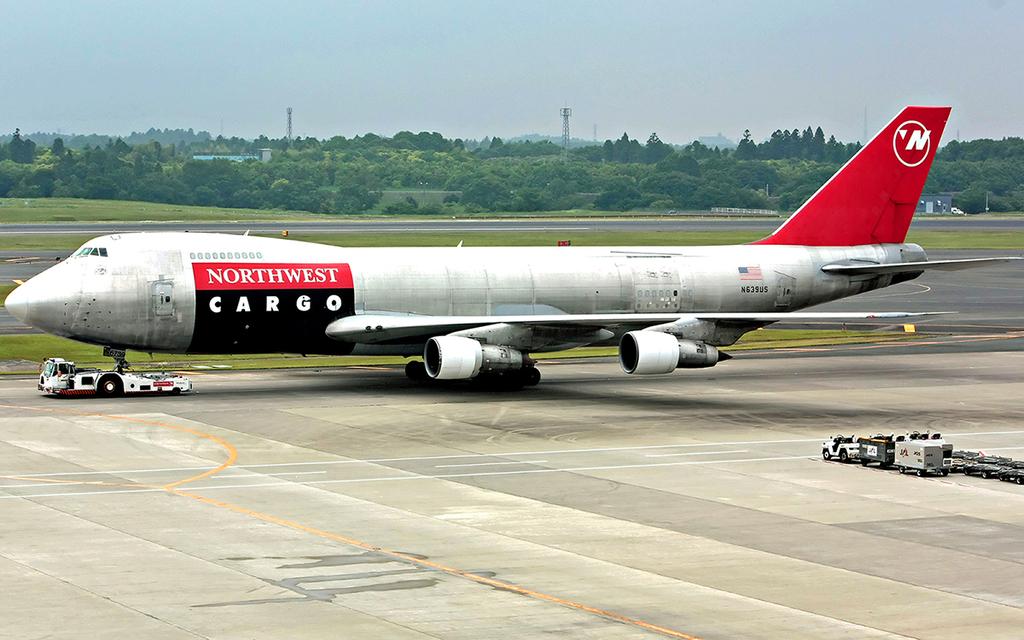What company is this plane under / owned / made by?
Your response must be concise. Northwest. 